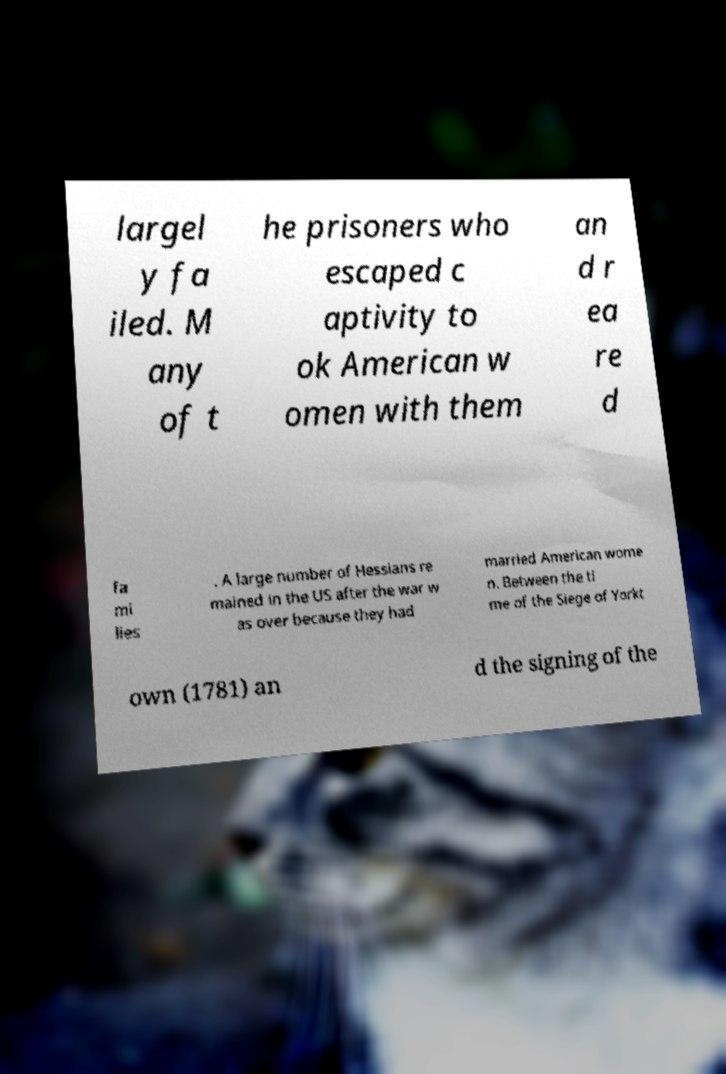There's text embedded in this image that I need extracted. Can you transcribe it verbatim? largel y fa iled. M any of t he prisoners who escaped c aptivity to ok American w omen with them an d r ea re d fa mi lies . A large number of Hessians re mained in the US after the war w as over because they had married American wome n. Between the ti me of the Siege of Yorkt own (1781) an d the signing of the 